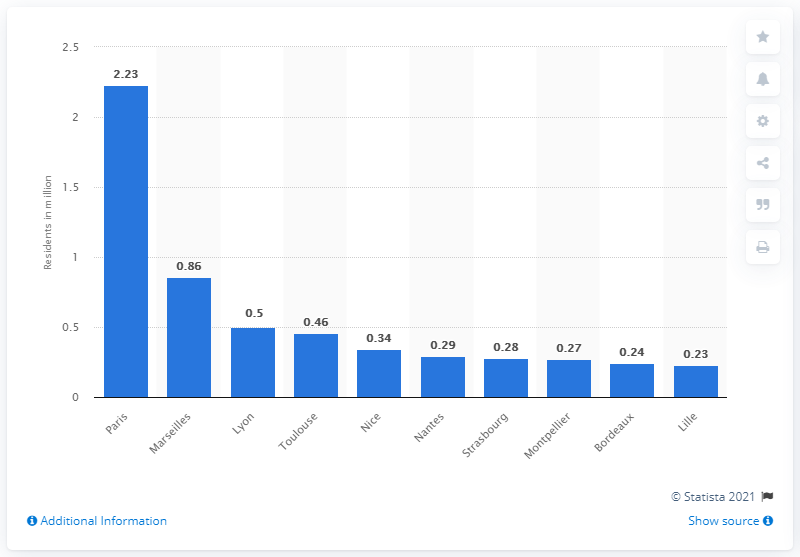Outline some significant characteristics in this image. In 2013, it is estimated that approximately 2.23 million people lived in the city of Paris. 